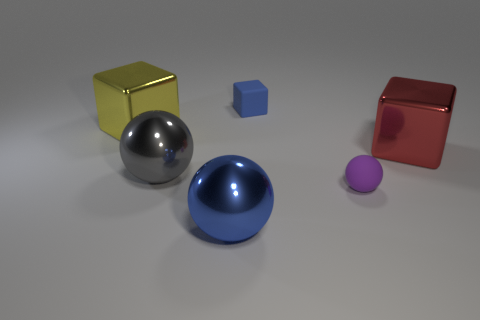What number of metal things are the same color as the tiny block?
Provide a short and direct response. 1. What size is the blue cube that is made of the same material as the small purple sphere?
Provide a short and direct response. Small. What size is the blue thing behind the shiny cube on the right side of the cube on the left side of the small blue thing?
Offer a very short reply. Small. There is a blue object behind the large red metal object; how big is it?
Offer a very short reply. Small. How many green objects are either small matte blocks or blocks?
Provide a short and direct response. 0. Is there a red metallic block of the same size as the yellow metal object?
Your response must be concise. Yes. What is the material of the blue object that is the same size as the gray thing?
Provide a short and direct response. Metal. There is a cube left of the small cube; is its size the same as the sphere that is right of the small blue cube?
Keep it short and to the point. No. How many objects are either blue matte cylinders or metal spheres in front of the big gray metal ball?
Provide a succinct answer. 1. Is there another small purple object that has the same shape as the purple thing?
Offer a terse response. No. 